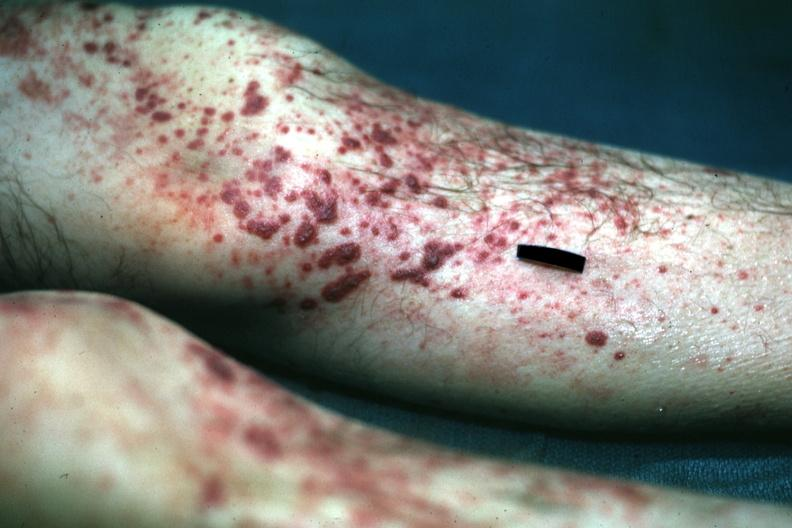what is present?
Answer the question using a single word or phrase. Palpable purpura 